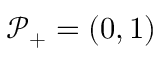Convert formula to latex. <formula><loc_0><loc_0><loc_500><loc_500>\mathcal { P } _ { + } = ( 0 , 1 )</formula> 